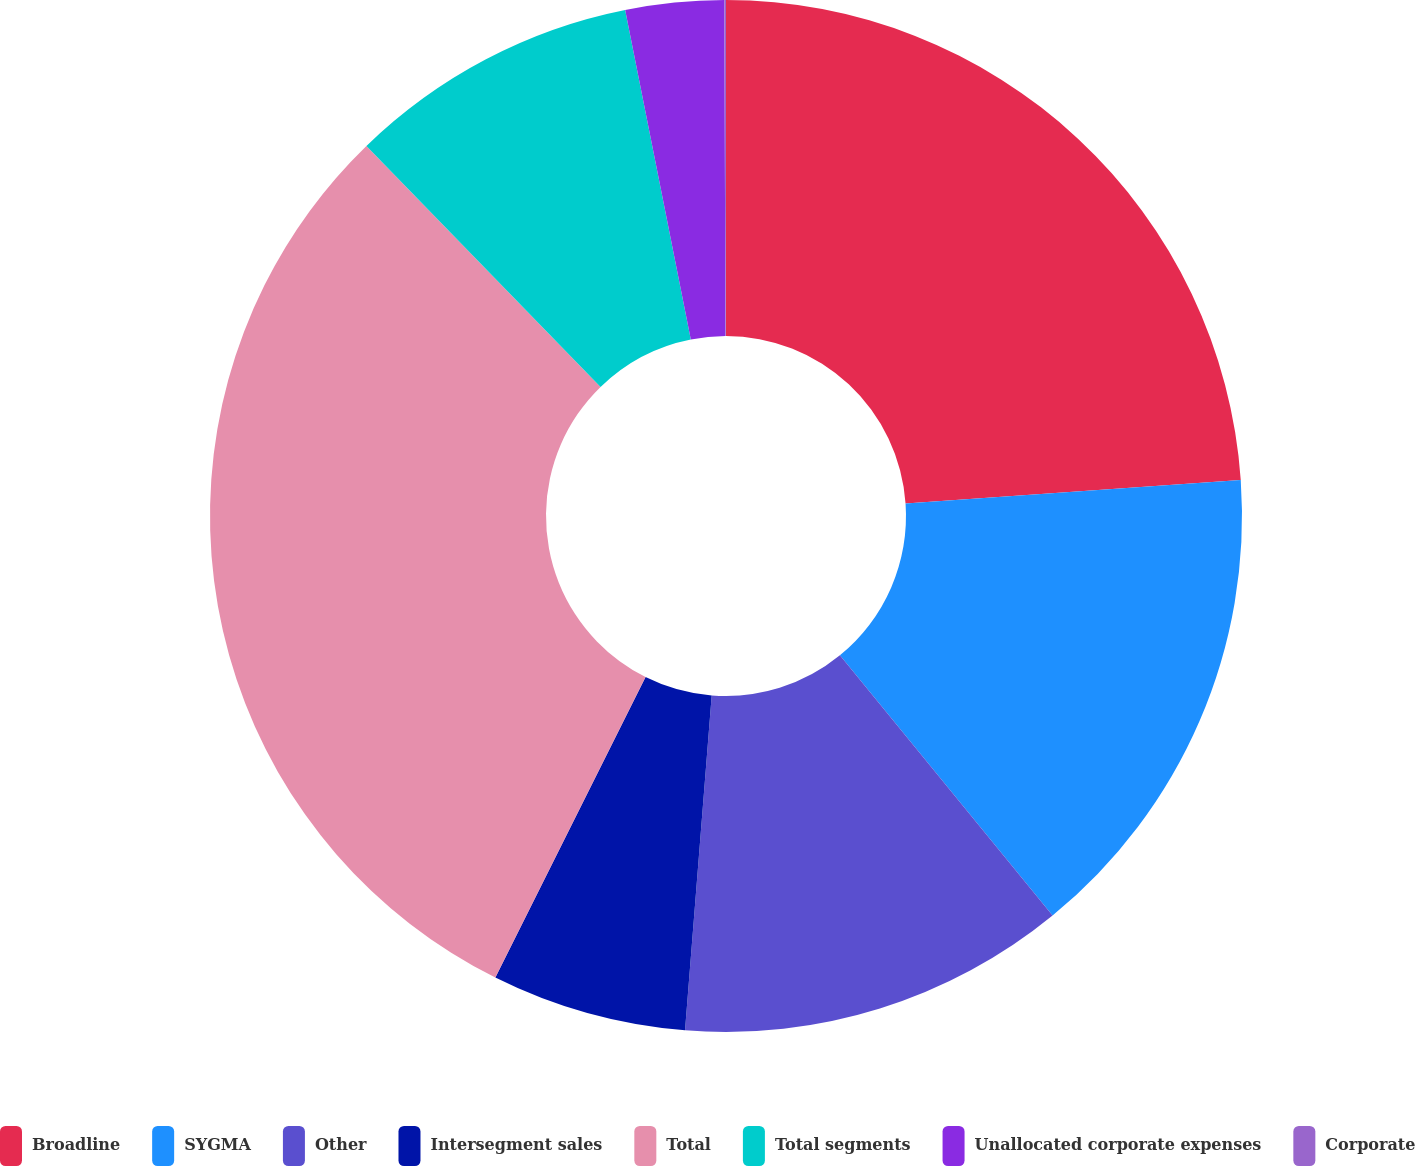Convert chart. <chart><loc_0><loc_0><loc_500><loc_500><pie_chart><fcel>Broadline<fcel>SYGMA<fcel>Other<fcel>Intersegment sales<fcel>Total<fcel>Total segments<fcel>Unallocated corporate expenses<fcel>Corporate<nl><fcel>23.89%<fcel>15.2%<fcel>12.17%<fcel>6.11%<fcel>30.35%<fcel>9.14%<fcel>3.08%<fcel>0.05%<nl></chart> 